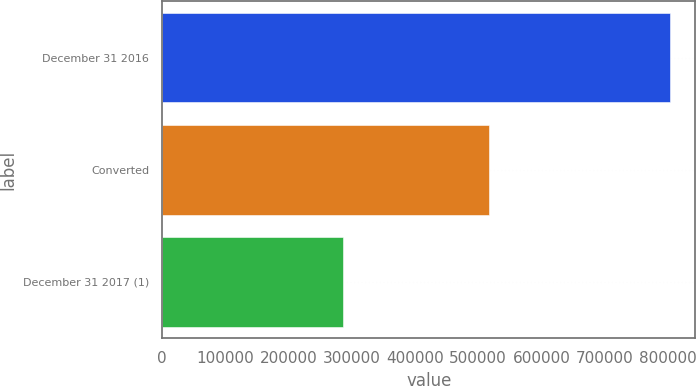Convert chart. <chart><loc_0><loc_0><loc_500><loc_500><bar_chart><fcel>December 31 2016<fcel>Converted<fcel>December 31 2017 (1)<nl><fcel>803474<fcel>517138<fcel>286336<nl></chart> 